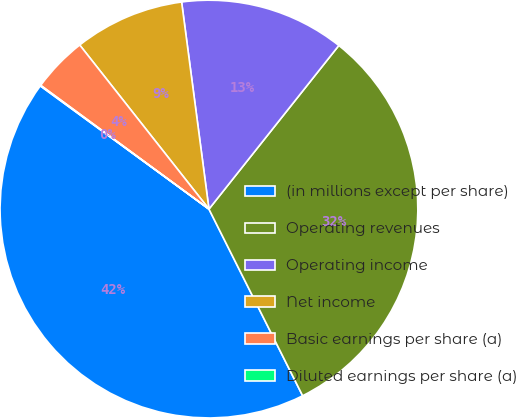Convert chart. <chart><loc_0><loc_0><loc_500><loc_500><pie_chart><fcel>(in millions except per share)<fcel>Operating revenues<fcel>Operating income<fcel>Net income<fcel>Basic earnings per share (a)<fcel>Diluted earnings per share (a)<nl><fcel>42.45%<fcel>31.92%<fcel>12.77%<fcel>8.53%<fcel>4.29%<fcel>0.05%<nl></chart> 